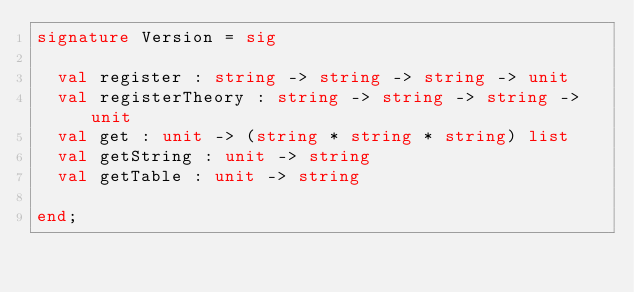<code> <loc_0><loc_0><loc_500><loc_500><_SML_>signature Version = sig

  val register : string -> string -> string -> unit
  val registerTheory : string -> string -> string -> unit
  val get : unit -> (string * string * string) list
  val getString : unit -> string
  val getTable : unit -> string

end;
</code> 